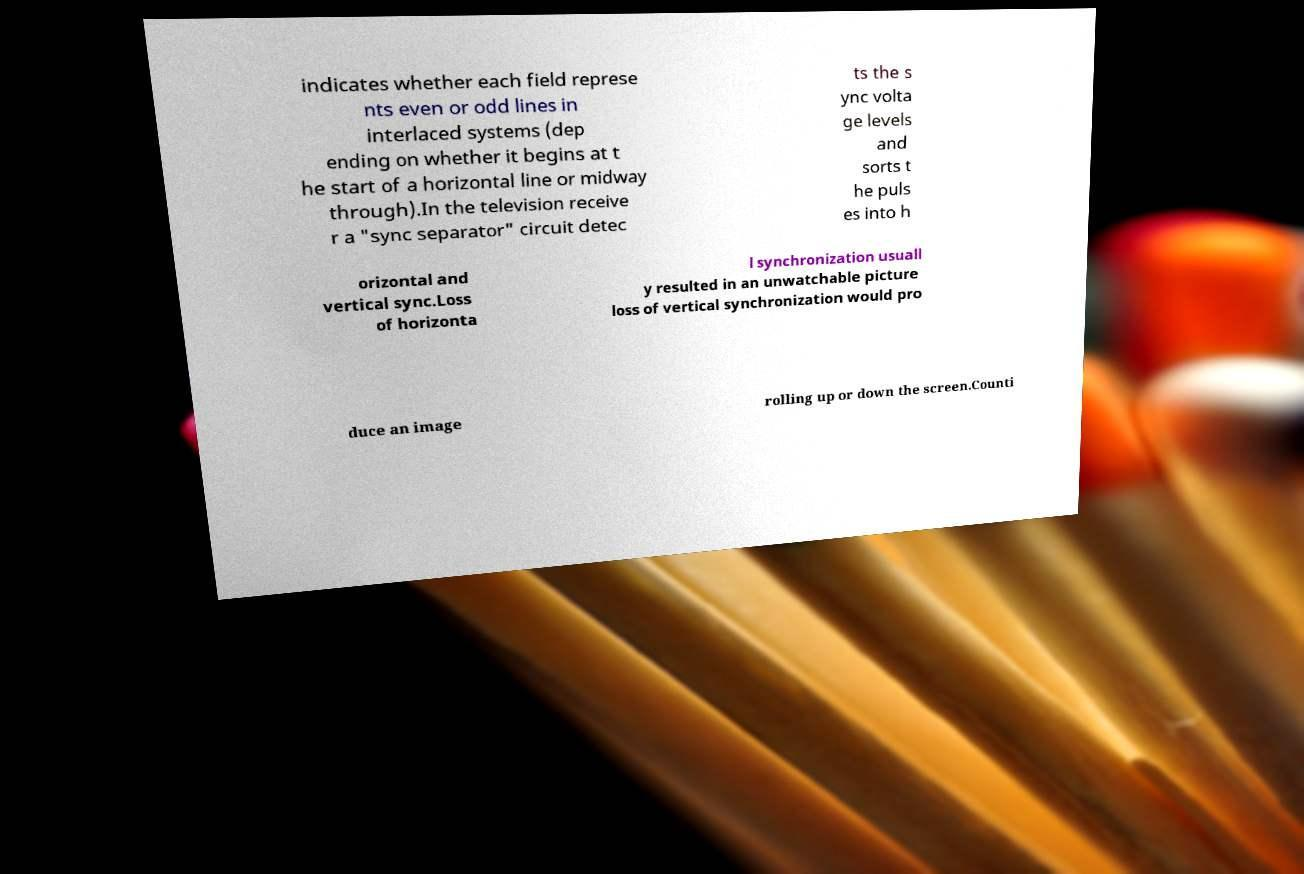Please read and relay the text visible in this image. What does it say? indicates whether each field represe nts even or odd lines in interlaced systems (dep ending on whether it begins at t he start of a horizontal line or midway through).In the television receive r a "sync separator" circuit detec ts the s ync volta ge levels and sorts t he puls es into h orizontal and vertical sync.Loss of horizonta l synchronization usuall y resulted in an unwatchable picture loss of vertical synchronization would pro duce an image rolling up or down the screen.Counti 